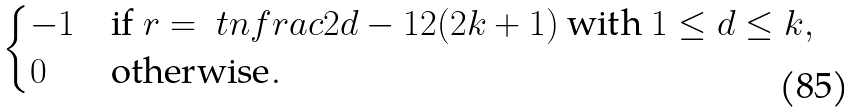<formula> <loc_0><loc_0><loc_500><loc_500>\begin{cases} - 1 & \text {if } r = \ t n f r a c { 2 d - 1 } { 2 ( 2 k + 1 ) } \text { with } 1 \leq d \leq k , \\ 0 & \text {otherwise} . \end{cases}</formula> 